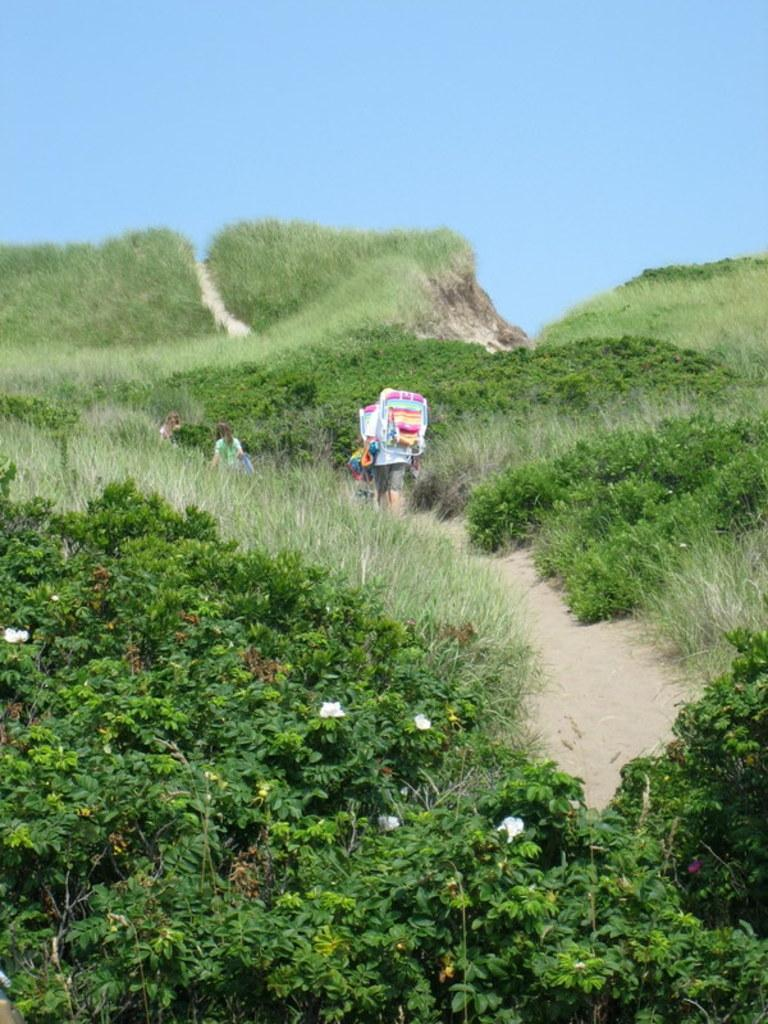What type of vegetation can be seen in the image? There are plants in the image. What is on the ground in the image? There is grass on the ground in the image. What can be seen in the image that people might walk on? There is a path in the image. What are the people in the image doing? People are walking on the path. What is visible in the background of the image? There is sky visible in the background of the image. What type of reaction does the yak have to the people walking on the path in the image? There is no yak present in the image, so it is not possible to determine any reaction. 